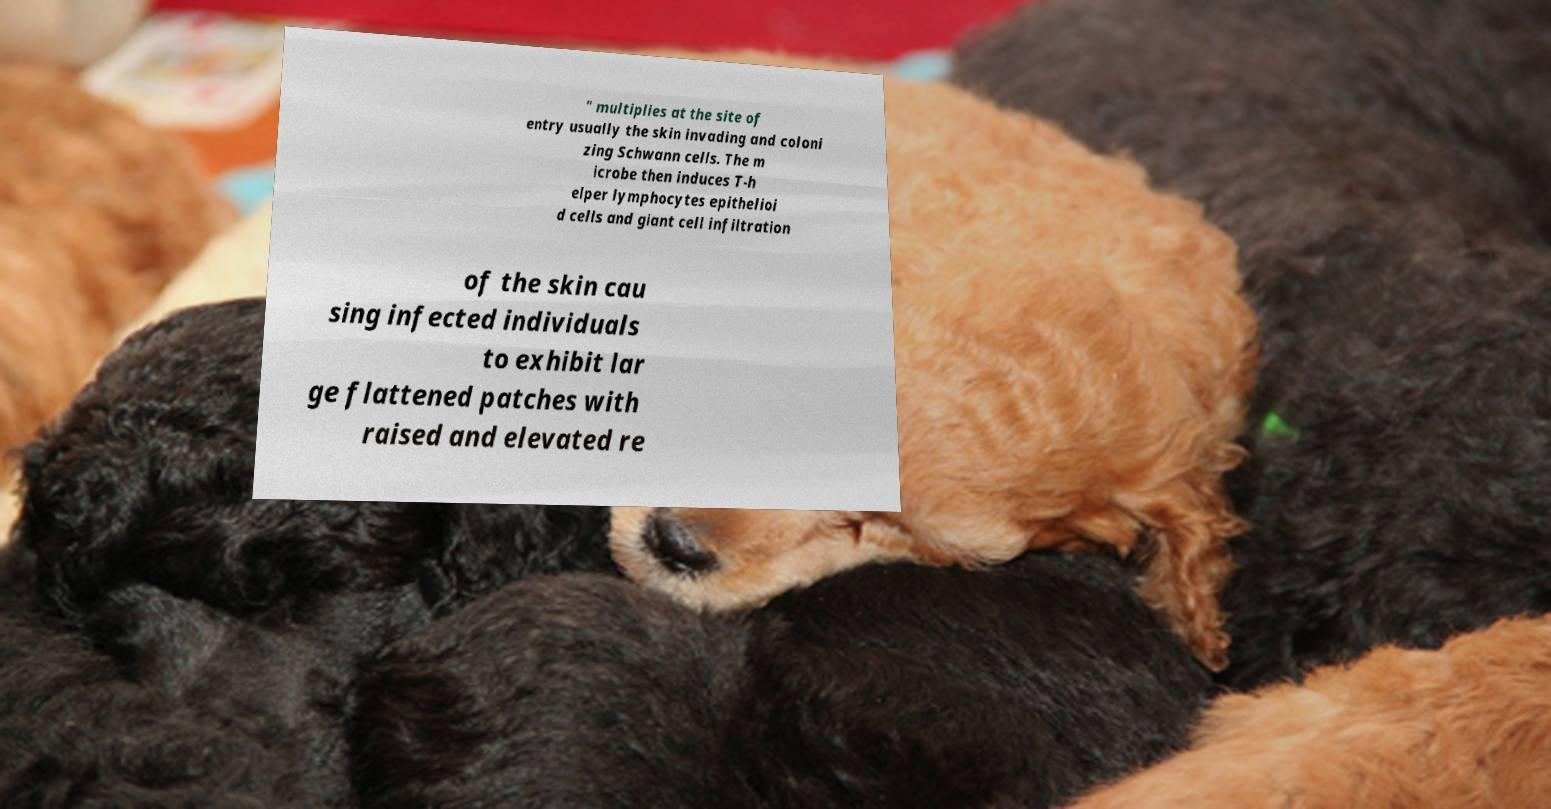What messages or text are displayed in this image? I need them in a readable, typed format. " multiplies at the site of entry usually the skin invading and coloni zing Schwann cells. The m icrobe then induces T-h elper lymphocytes epithelioi d cells and giant cell infiltration of the skin cau sing infected individuals to exhibit lar ge flattened patches with raised and elevated re 